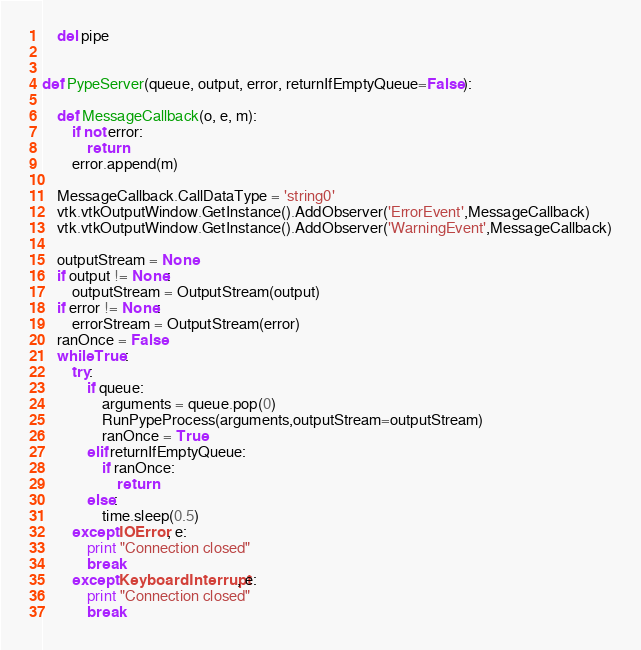<code> <loc_0><loc_0><loc_500><loc_500><_Python_>    del pipe


def PypeServer(queue, output, error, returnIfEmptyQueue=False):

    def MessageCallback(o, e, m):
        if not error:
            return
        error.append(m)

    MessageCallback.CallDataType = 'string0'
    vtk.vtkOutputWindow.GetInstance().AddObserver('ErrorEvent',MessageCallback)
    vtk.vtkOutputWindow.GetInstance().AddObserver('WarningEvent',MessageCallback)

    outputStream = None
    if output != None:
        outputStream = OutputStream(output)
    if error != None:
        errorStream = OutputStream(error)
    ranOnce = False
    while True:
        try:
            if queue:
                arguments = queue.pop(0)
                RunPypeProcess(arguments,outputStream=outputStream)
                ranOnce = True
            elif returnIfEmptyQueue:
                if ranOnce:
                    return
            else:
                time.sleep(0.5)
        except IOError, e:
            print "Connection closed"
            break
        except KeyboardInterrupt, e:
            print "Connection closed"
            break

</code> 